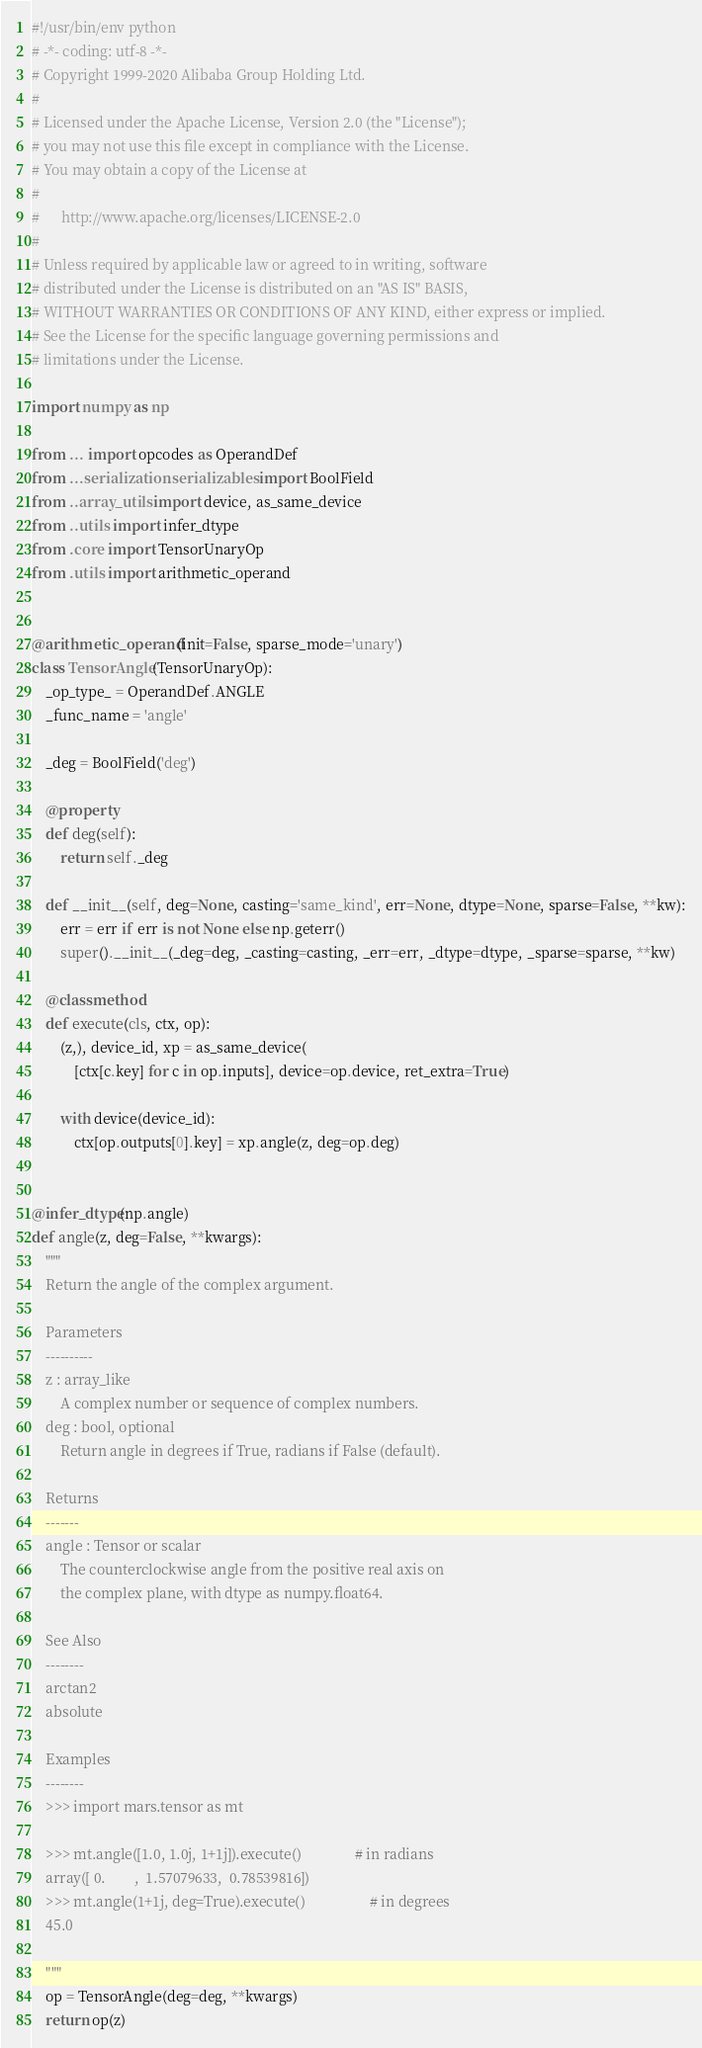<code> <loc_0><loc_0><loc_500><loc_500><_Python_>#!/usr/bin/env python
# -*- coding: utf-8 -*-
# Copyright 1999-2020 Alibaba Group Holding Ltd.
#
# Licensed under the Apache License, Version 2.0 (the "License");
# you may not use this file except in compliance with the License.
# You may obtain a copy of the License at
#
#      http://www.apache.org/licenses/LICENSE-2.0
#
# Unless required by applicable law or agreed to in writing, software
# distributed under the License is distributed on an "AS IS" BASIS,
# WITHOUT WARRANTIES OR CONDITIONS OF ANY KIND, either express or implied.
# See the License for the specific language governing permissions and
# limitations under the License.

import numpy as np

from ... import opcodes as OperandDef
from ...serialization.serializables import BoolField
from ..array_utils import device, as_same_device
from ..utils import infer_dtype
from .core import TensorUnaryOp
from .utils import arithmetic_operand


@arithmetic_operand(init=False, sparse_mode='unary')
class TensorAngle(TensorUnaryOp):
    _op_type_ = OperandDef.ANGLE
    _func_name = 'angle'

    _deg = BoolField('deg')

    @property
    def deg(self):
        return self._deg

    def __init__(self, deg=None, casting='same_kind', err=None, dtype=None, sparse=False, **kw):
        err = err if err is not None else np.geterr()
        super().__init__(_deg=deg, _casting=casting, _err=err, _dtype=dtype, _sparse=sparse, **kw)

    @classmethod
    def execute(cls, ctx, op):
        (z,), device_id, xp = as_same_device(
            [ctx[c.key] for c in op.inputs], device=op.device, ret_extra=True)

        with device(device_id):
            ctx[op.outputs[0].key] = xp.angle(z, deg=op.deg)


@infer_dtype(np.angle)
def angle(z, deg=False, **kwargs):
    """
    Return the angle of the complex argument.

    Parameters
    ----------
    z : array_like
        A complex number or sequence of complex numbers.
    deg : bool, optional
        Return angle in degrees if True, radians if False (default).

    Returns
    -------
    angle : Tensor or scalar
        The counterclockwise angle from the positive real axis on
        the complex plane, with dtype as numpy.float64.

    See Also
    --------
    arctan2
    absolute

    Examples
    --------
    >>> import mars.tensor as mt

    >>> mt.angle([1.0, 1.0j, 1+1j]).execute()               # in radians
    array([ 0.        ,  1.57079633,  0.78539816])
    >>> mt.angle(1+1j, deg=True).execute()                  # in degrees
    45.0

    """
    op = TensorAngle(deg=deg, **kwargs)
    return op(z)
</code> 